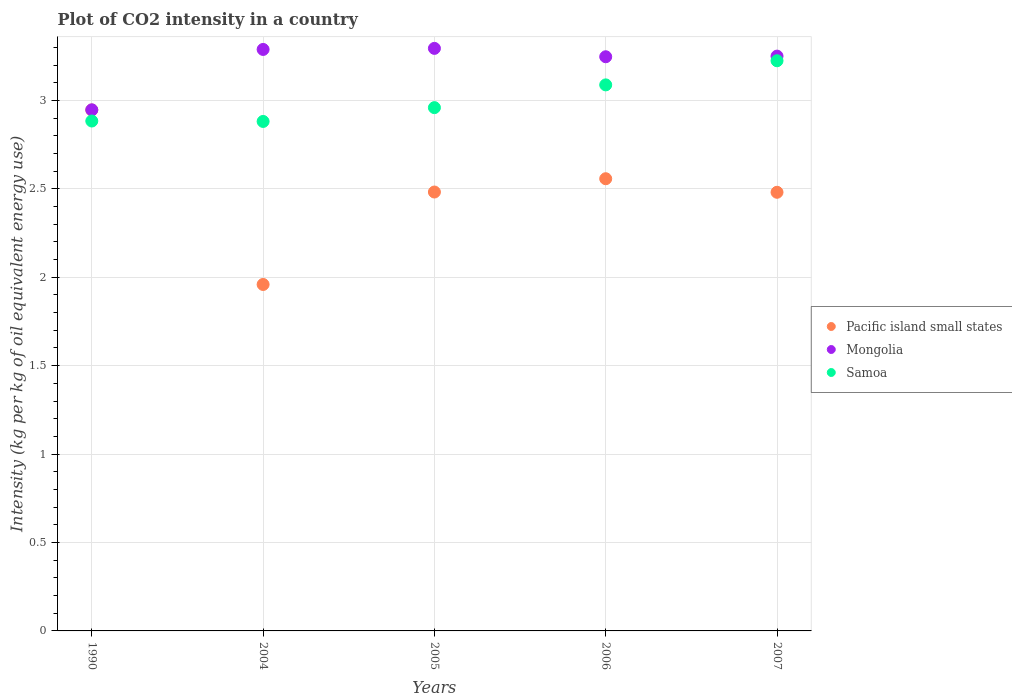How many different coloured dotlines are there?
Your response must be concise. 3. What is the CO2 intensity in in Pacific island small states in 1990?
Your answer should be very brief. 2.95. Across all years, what is the maximum CO2 intensity in in Pacific island small states?
Offer a terse response. 2.95. Across all years, what is the minimum CO2 intensity in in Samoa?
Your answer should be very brief. 2.88. In which year was the CO2 intensity in in Samoa maximum?
Offer a terse response. 2007. What is the total CO2 intensity in in Pacific island small states in the graph?
Give a very brief answer. 12.43. What is the difference between the CO2 intensity in in Mongolia in 2004 and that in 2006?
Your answer should be very brief. 0.04. What is the difference between the CO2 intensity in in Pacific island small states in 1990 and the CO2 intensity in in Mongolia in 2007?
Make the answer very short. -0.3. What is the average CO2 intensity in in Samoa per year?
Offer a terse response. 3.01. In the year 2004, what is the difference between the CO2 intensity in in Mongolia and CO2 intensity in in Pacific island small states?
Provide a succinct answer. 1.33. What is the ratio of the CO2 intensity in in Samoa in 2004 to that in 2007?
Provide a short and direct response. 0.89. What is the difference between the highest and the second highest CO2 intensity in in Mongolia?
Ensure brevity in your answer.  0.01. What is the difference between the highest and the lowest CO2 intensity in in Mongolia?
Give a very brief answer. 0.35. In how many years, is the CO2 intensity in in Pacific island small states greater than the average CO2 intensity in in Pacific island small states taken over all years?
Offer a very short reply. 2. Is the sum of the CO2 intensity in in Pacific island small states in 2004 and 2005 greater than the maximum CO2 intensity in in Mongolia across all years?
Give a very brief answer. Yes. Is it the case that in every year, the sum of the CO2 intensity in in Samoa and CO2 intensity in in Pacific island small states  is greater than the CO2 intensity in in Mongolia?
Provide a succinct answer. Yes. Does the CO2 intensity in in Pacific island small states monotonically increase over the years?
Offer a terse response. No. Is the CO2 intensity in in Mongolia strictly greater than the CO2 intensity in in Pacific island small states over the years?
Your response must be concise. Yes. What is the difference between two consecutive major ticks on the Y-axis?
Offer a terse response. 0.5. Are the values on the major ticks of Y-axis written in scientific E-notation?
Give a very brief answer. No. Does the graph contain any zero values?
Offer a very short reply. No. What is the title of the graph?
Offer a terse response. Plot of CO2 intensity in a country. Does "Japan" appear as one of the legend labels in the graph?
Your answer should be very brief. No. What is the label or title of the X-axis?
Your answer should be very brief. Years. What is the label or title of the Y-axis?
Provide a succinct answer. Intensity (kg per kg of oil equivalent energy use). What is the Intensity (kg per kg of oil equivalent energy use) in Pacific island small states in 1990?
Your answer should be very brief. 2.95. What is the Intensity (kg per kg of oil equivalent energy use) of Mongolia in 1990?
Your response must be concise. 2.95. What is the Intensity (kg per kg of oil equivalent energy use) in Samoa in 1990?
Ensure brevity in your answer.  2.88. What is the Intensity (kg per kg of oil equivalent energy use) of Pacific island small states in 2004?
Offer a terse response. 1.96. What is the Intensity (kg per kg of oil equivalent energy use) in Mongolia in 2004?
Provide a succinct answer. 3.29. What is the Intensity (kg per kg of oil equivalent energy use) in Samoa in 2004?
Make the answer very short. 2.88. What is the Intensity (kg per kg of oil equivalent energy use) in Pacific island small states in 2005?
Provide a short and direct response. 2.48. What is the Intensity (kg per kg of oil equivalent energy use) in Mongolia in 2005?
Your answer should be compact. 3.29. What is the Intensity (kg per kg of oil equivalent energy use) in Samoa in 2005?
Offer a very short reply. 2.96. What is the Intensity (kg per kg of oil equivalent energy use) of Pacific island small states in 2006?
Provide a succinct answer. 2.56. What is the Intensity (kg per kg of oil equivalent energy use) in Mongolia in 2006?
Provide a succinct answer. 3.25. What is the Intensity (kg per kg of oil equivalent energy use) of Samoa in 2006?
Keep it short and to the point. 3.09. What is the Intensity (kg per kg of oil equivalent energy use) in Pacific island small states in 2007?
Offer a terse response. 2.48. What is the Intensity (kg per kg of oil equivalent energy use) in Mongolia in 2007?
Provide a succinct answer. 3.25. What is the Intensity (kg per kg of oil equivalent energy use) in Samoa in 2007?
Offer a very short reply. 3.22. Across all years, what is the maximum Intensity (kg per kg of oil equivalent energy use) of Pacific island small states?
Offer a very short reply. 2.95. Across all years, what is the maximum Intensity (kg per kg of oil equivalent energy use) of Mongolia?
Offer a terse response. 3.29. Across all years, what is the maximum Intensity (kg per kg of oil equivalent energy use) of Samoa?
Make the answer very short. 3.22. Across all years, what is the minimum Intensity (kg per kg of oil equivalent energy use) in Pacific island small states?
Your response must be concise. 1.96. Across all years, what is the minimum Intensity (kg per kg of oil equivalent energy use) of Mongolia?
Offer a very short reply. 2.95. Across all years, what is the minimum Intensity (kg per kg of oil equivalent energy use) of Samoa?
Offer a very short reply. 2.88. What is the total Intensity (kg per kg of oil equivalent energy use) in Pacific island small states in the graph?
Give a very brief answer. 12.43. What is the total Intensity (kg per kg of oil equivalent energy use) in Mongolia in the graph?
Make the answer very short. 16.03. What is the total Intensity (kg per kg of oil equivalent energy use) of Samoa in the graph?
Give a very brief answer. 15.04. What is the difference between the Intensity (kg per kg of oil equivalent energy use) in Pacific island small states in 1990 and that in 2004?
Make the answer very short. 0.99. What is the difference between the Intensity (kg per kg of oil equivalent energy use) of Mongolia in 1990 and that in 2004?
Offer a terse response. -0.34. What is the difference between the Intensity (kg per kg of oil equivalent energy use) in Samoa in 1990 and that in 2004?
Provide a short and direct response. 0. What is the difference between the Intensity (kg per kg of oil equivalent energy use) in Pacific island small states in 1990 and that in 2005?
Offer a very short reply. 0.46. What is the difference between the Intensity (kg per kg of oil equivalent energy use) of Mongolia in 1990 and that in 2005?
Provide a short and direct response. -0.35. What is the difference between the Intensity (kg per kg of oil equivalent energy use) of Samoa in 1990 and that in 2005?
Give a very brief answer. -0.08. What is the difference between the Intensity (kg per kg of oil equivalent energy use) of Pacific island small states in 1990 and that in 2006?
Ensure brevity in your answer.  0.39. What is the difference between the Intensity (kg per kg of oil equivalent energy use) of Mongolia in 1990 and that in 2006?
Keep it short and to the point. -0.3. What is the difference between the Intensity (kg per kg of oil equivalent energy use) of Samoa in 1990 and that in 2006?
Your answer should be compact. -0.2. What is the difference between the Intensity (kg per kg of oil equivalent energy use) of Pacific island small states in 1990 and that in 2007?
Your answer should be very brief. 0.47. What is the difference between the Intensity (kg per kg of oil equivalent energy use) of Mongolia in 1990 and that in 2007?
Keep it short and to the point. -0.3. What is the difference between the Intensity (kg per kg of oil equivalent energy use) in Samoa in 1990 and that in 2007?
Ensure brevity in your answer.  -0.34. What is the difference between the Intensity (kg per kg of oil equivalent energy use) in Pacific island small states in 2004 and that in 2005?
Keep it short and to the point. -0.52. What is the difference between the Intensity (kg per kg of oil equivalent energy use) in Mongolia in 2004 and that in 2005?
Ensure brevity in your answer.  -0.01. What is the difference between the Intensity (kg per kg of oil equivalent energy use) of Samoa in 2004 and that in 2005?
Offer a very short reply. -0.08. What is the difference between the Intensity (kg per kg of oil equivalent energy use) of Pacific island small states in 2004 and that in 2006?
Provide a short and direct response. -0.6. What is the difference between the Intensity (kg per kg of oil equivalent energy use) in Mongolia in 2004 and that in 2006?
Ensure brevity in your answer.  0.04. What is the difference between the Intensity (kg per kg of oil equivalent energy use) in Samoa in 2004 and that in 2006?
Provide a succinct answer. -0.21. What is the difference between the Intensity (kg per kg of oil equivalent energy use) in Pacific island small states in 2004 and that in 2007?
Your answer should be very brief. -0.52. What is the difference between the Intensity (kg per kg of oil equivalent energy use) of Mongolia in 2004 and that in 2007?
Your answer should be very brief. 0.04. What is the difference between the Intensity (kg per kg of oil equivalent energy use) of Samoa in 2004 and that in 2007?
Your answer should be very brief. -0.34. What is the difference between the Intensity (kg per kg of oil equivalent energy use) in Pacific island small states in 2005 and that in 2006?
Offer a very short reply. -0.08. What is the difference between the Intensity (kg per kg of oil equivalent energy use) in Mongolia in 2005 and that in 2006?
Provide a succinct answer. 0.05. What is the difference between the Intensity (kg per kg of oil equivalent energy use) in Samoa in 2005 and that in 2006?
Provide a short and direct response. -0.13. What is the difference between the Intensity (kg per kg of oil equivalent energy use) in Pacific island small states in 2005 and that in 2007?
Offer a very short reply. 0. What is the difference between the Intensity (kg per kg of oil equivalent energy use) in Mongolia in 2005 and that in 2007?
Give a very brief answer. 0.04. What is the difference between the Intensity (kg per kg of oil equivalent energy use) of Samoa in 2005 and that in 2007?
Your answer should be compact. -0.27. What is the difference between the Intensity (kg per kg of oil equivalent energy use) in Pacific island small states in 2006 and that in 2007?
Offer a terse response. 0.08. What is the difference between the Intensity (kg per kg of oil equivalent energy use) of Mongolia in 2006 and that in 2007?
Provide a short and direct response. -0. What is the difference between the Intensity (kg per kg of oil equivalent energy use) in Samoa in 2006 and that in 2007?
Make the answer very short. -0.14. What is the difference between the Intensity (kg per kg of oil equivalent energy use) in Pacific island small states in 1990 and the Intensity (kg per kg of oil equivalent energy use) in Mongolia in 2004?
Keep it short and to the point. -0.34. What is the difference between the Intensity (kg per kg of oil equivalent energy use) in Pacific island small states in 1990 and the Intensity (kg per kg of oil equivalent energy use) in Samoa in 2004?
Your answer should be compact. 0.06. What is the difference between the Intensity (kg per kg of oil equivalent energy use) of Mongolia in 1990 and the Intensity (kg per kg of oil equivalent energy use) of Samoa in 2004?
Your answer should be very brief. 0.07. What is the difference between the Intensity (kg per kg of oil equivalent energy use) of Pacific island small states in 1990 and the Intensity (kg per kg of oil equivalent energy use) of Mongolia in 2005?
Give a very brief answer. -0.35. What is the difference between the Intensity (kg per kg of oil equivalent energy use) in Pacific island small states in 1990 and the Intensity (kg per kg of oil equivalent energy use) in Samoa in 2005?
Offer a very short reply. -0.01. What is the difference between the Intensity (kg per kg of oil equivalent energy use) of Mongolia in 1990 and the Intensity (kg per kg of oil equivalent energy use) of Samoa in 2005?
Your answer should be compact. -0.01. What is the difference between the Intensity (kg per kg of oil equivalent energy use) of Pacific island small states in 1990 and the Intensity (kg per kg of oil equivalent energy use) of Mongolia in 2006?
Provide a short and direct response. -0.3. What is the difference between the Intensity (kg per kg of oil equivalent energy use) of Pacific island small states in 1990 and the Intensity (kg per kg of oil equivalent energy use) of Samoa in 2006?
Keep it short and to the point. -0.14. What is the difference between the Intensity (kg per kg of oil equivalent energy use) of Mongolia in 1990 and the Intensity (kg per kg of oil equivalent energy use) of Samoa in 2006?
Provide a short and direct response. -0.14. What is the difference between the Intensity (kg per kg of oil equivalent energy use) of Pacific island small states in 1990 and the Intensity (kg per kg of oil equivalent energy use) of Mongolia in 2007?
Your answer should be compact. -0.3. What is the difference between the Intensity (kg per kg of oil equivalent energy use) in Pacific island small states in 1990 and the Intensity (kg per kg of oil equivalent energy use) in Samoa in 2007?
Your answer should be very brief. -0.28. What is the difference between the Intensity (kg per kg of oil equivalent energy use) in Mongolia in 1990 and the Intensity (kg per kg of oil equivalent energy use) in Samoa in 2007?
Your response must be concise. -0.28. What is the difference between the Intensity (kg per kg of oil equivalent energy use) of Pacific island small states in 2004 and the Intensity (kg per kg of oil equivalent energy use) of Mongolia in 2005?
Keep it short and to the point. -1.34. What is the difference between the Intensity (kg per kg of oil equivalent energy use) in Pacific island small states in 2004 and the Intensity (kg per kg of oil equivalent energy use) in Samoa in 2005?
Give a very brief answer. -1. What is the difference between the Intensity (kg per kg of oil equivalent energy use) of Mongolia in 2004 and the Intensity (kg per kg of oil equivalent energy use) of Samoa in 2005?
Your response must be concise. 0.33. What is the difference between the Intensity (kg per kg of oil equivalent energy use) in Pacific island small states in 2004 and the Intensity (kg per kg of oil equivalent energy use) in Mongolia in 2006?
Make the answer very short. -1.29. What is the difference between the Intensity (kg per kg of oil equivalent energy use) of Pacific island small states in 2004 and the Intensity (kg per kg of oil equivalent energy use) of Samoa in 2006?
Provide a succinct answer. -1.13. What is the difference between the Intensity (kg per kg of oil equivalent energy use) of Mongolia in 2004 and the Intensity (kg per kg of oil equivalent energy use) of Samoa in 2006?
Your answer should be compact. 0.2. What is the difference between the Intensity (kg per kg of oil equivalent energy use) in Pacific island small states in 2004 and the Intensity (kg per kg of oil equivalent energy use) in Mongolia in 2007?
Your answer should be very brief. -1.29. What is the difference between the Intensity (kg per kg of oil equivalent energy use) of Pacific island small states in 2004 and the Intensity (kg per kg of oil equivalent energy use) of Samoa in 2007?
Provide a succinct answer. -1.27. What is the difference between the Intensity (kg per kg of oil equivalent energy use) in Mongolia in 2004 and the Intensity (kg per kg of oil equivalent energy use) in Samoa in 2007?
Offer a very short reply. 0.06. What is the difference between the Intensity (kg per kg of oil equivalent energy use) in Pacific island small states in 2005 and the Intensity (kg per kg of oil equivalent energy use) in Mongolia in 2006?
Offer a terse response. -0.77. What is the difference between the Intensity (kg per kg of oil equivalent energy use) in Pacific island small states in 2005 and the Intensity (kg per kg of oil equivalent energy use) in Samoa in 2006?
Ensure brevity in your answer.  -0.61. What is the difference between the Intensity (kg per kg of oil equivalent energy use) of Mongolia in 2005 and the Intensity (kg per kg of oil equivalent energy use) of Samoa in 2006?
Give a very brief answer. 0.21. What is the difference between the Intensity (kg per kg of oil equivalent energy use) of Pacific island small states in 2005 and the Intensity (kg per kg of oil equivalent energy use) of Mongolia in 2007?
Your answer should be compact. -0.77. What is the difference between the Intensity (kg per kg of oil equivalent energy use) of Pacific island small states in 2005 and the Intensity (kg per kg of oil equivalent energy use) of Samoa in 2007?
Provide a succinct answer. -0.74. What is the difference between the Intensity (kg per kg of oil equivalent energy use) of Mongolia in 2005 and the Intensity (kg per kg of oil equivalent energy use) of Samoa in 2007?
Provide a succinct answer. 0.07. What is the difference between the Intensity (kg per kg of oil equivalent energy use) of Pacific island small states in 2006 and the Intensity (kg per kg of oil equivalent energy use) of Mongolia in 2007?
Ensure brevity in your answer.  -0.69. What is the difference between the Intensity (kg per kg of oil equivalent energy use) of Pacific island small states in 2006 and the Intensity (kg per kg of oil equivalent energy use) of Samoa in 2007?
Provide a succinct answer. -0.67. What is the difference between the Intensity (kg per kg of oil equivalent energy use) of Mongolia in 2006 and the Intensity (kg per kg of oil equivalent energy use) of Samoa in 2007?
Offer a very short reply. 0.02. What is the average Intensity (kg per kg of oil equivalent energy use) in Pacific island small states per year?
Give a very brief answer. 2.48. What is the average Intensity (kg per kg of oil equivalent energy use) in Mongolia per year?
Keep it short and to the point. 3.21. What is the average Intensity (kg per kg of oil equivalent energy use) in Samoa per year?
Provide a short and direct response. 3.01. In the year 1990, what is the difference between the Intensity (kg per kg of oil equivalent energy use) of Pacific island small states and Intensity (kg per kg of oil equivalent energy use) of Mongolia?
Your answer should be compact. -0. In the year 1990, what is the difference between the Intensity (kg per kg of oil equivalent energy use) of Pacific island small states and Intensity (kg per kg of oil equivalent energy use) of Samoa?
Ensure brevity in your answer.  0.06. In the year 1990, what is the difference between the Intensity (kg per kg of oil equivalent energy use) of Mongolia and Intensity (kg per kg of oil equivalent energy use) of Samoa?
Your answer should be very brief. 0.06. In the year 2004, what is the difference between the Intensity (kg per kg of oil equivalent energy use) in Pacific island small states and Intensity (kg per kg of oil equivalent energy use) in Mongolia?
Ensure brevity in your answer.  -1.33. In the year 2004, what is the difference between the Intensity (kg per kg of oil equivalent energy use) in Pacific island small states and Intensity (kg per kg of oil equivalent energy use) in Samoa?
Your answer should be very brief. -0.92. In the year 2004, what is the difference between the Intensity (kg per kg of oil equivalent energy use) of Mongolia and Intensity (kg per kg of oil equivalent energy use) of Samoa?
Your response must be concise. 0.41. In the year 2005, what is the difference between the Intensity (kg per kg of oil equivalent energy use) of Pacific island small states and Intensity (kg per kg of oil equivalent energy use) of Mongolia?
Offer a very short reply. -0.81. In the year 2005, what is the difference between the Intensity (kg per kg of oil equivalent energy use) in Pacific island small states and Intensity (kg per kg of oil equivalent energy use) in Samoa?
Offer a very short reply. -0.48. In the year 2005, what is the difference between the Intensity (kg per kg of oil equivalent energy use) of Mongolia and Intensity (kg per kg of oil equivalent energy use) of Samoa?
Your answer should be very brief. 0.34. In the year 2006, what is the difference between the Intensity (kg per kg of oil equivalent energy use) of Pacific island small states and Intensity (kg per kg of oil equivalent energy use) of Mongolia?
Give a very brief answer. -0.69. In the year 2006, what is the difference between the Intensity (kg per kg of oil equivalent energy use) in Pacific island small states and Intensity (kg per kg of oil equivalent energy use) in Samoa?
Provide a succinct answer. -0.53. In the year 2006, what is the difference between the Intensity (kg per kg of oil equivalent energy use) in Mongolia and Intensity (kg per kg of oil equivalent energy use) in Samoa?
Offer a terse response. 0.16. In the year 2007, what is the difference between the Intensity (kg per kg of oil equivalent energy use) in Pacific island small states and Intensity (kg per kg of oil equivalent energy use) in Mongolia?
Offer a terse response. -0.77. In the year 2007, what is the difference between the Intensity (kg per kg of oil equivalent energy use) of Pacific island small states and Intensity (kg per kg of oil equivalent energy use) of Samoa?
Make the answer very short. -0.74. In the year 2007, what is the difference between the Intensity (kg per kg of oil equivalent energy use) in Mongolia and Intensity (kg per kg of oil equivalent energy use) in Samoa?
Offer a very short reply. 0.03. What is the ratio of the Intensity (kg per kg of oil equivalent energy use) in Pacific island small states in 1990 to that in 2004?
Keep it short and to the point. 1.5. What is the ratio of the Intensity (kg per kg of oil equivalent energy use) of Mongolia in 1990 to that in 2004?
Your response must be concise. 0.9. What is the ratio of the Intensity (kg per kg of oil equivalent energy use) in Pacific island small states in 1990 to that in 2005?
Give a very brief answer. 1.19. What is the ratio of the Intensity (kg per kg of oil equivalent energy use) in Mongolia in 1990 to that in 2005?
Make the answer very short. 0.89. What is the ratio of the Intensity (kg per kg of oil equivalent energy use) of Samoa in 1990 to that in 2005?
Your answer should be very brief. 0.97. What is the ratio of the Intensity (kg per kg of oil equivalent energy use) of Pacific island small states in 1990 to that in 2006?
Keep it short and to the point. 1.15. What is the ratio of the Intensity (kg per kg of oil equivalent energy use) in Mongolia in 1990 to that in 2006?
Keep it short and to the point. 0.91. What is the ratio of the Intensity (kg per kg of oil equivalent energy use) of Samoa in 1990 to that in 2006?
Give a very brief answer. 0.93. What is the ratio of the Intensity (kg per kg of oil equivalent energy use) in Pacific island small states in 1990 to that in 2007?
Offer a terse response. 1.19. What is the ratio of the Intensity (kg per kg of oil equivalent energy use) of Mongolia in 1990 to that in 2007?
Your answer should be very brief. 0.91. What is the ratio of the Intensity (kg per kg of oil equivalent energy use) in Samoa in 1990 to that in 2007?
Your response must be concise. 0.89. What is the ratio of the Intensity (kg per kg of oil equivalent energy use) in Pacific island small states in 2004 to that in 2005?
Your response must be concise. 0.79. What is the ratio of the Intensity (kg per kg of oil equivalent energy use) of Mongolia in 2004 to that in 2005?
Ensure brevity in your answer.  1. What is the ratio of the Intensity (kg per kg of oil equivalent energy use) of Samoa in 2004 to that in 2005?
Provide a succinct answer. 0.97. What is the ratio of the Intensity (kg per kg of oil equivalent energy use) of Pacific island small states in 2004 to that in 2006?
Your answer should be compact. 0.77. What is the ratio of the Intensity (kg per kg of oil equivalent energy use) in Mongolia in 2004 to that in 2006?
Your answer should be compact. 1.01. What is the ratio of the Intensity (kg per kg of oil equivalent energy use) in Samoa in 2004 to that in 2006?
Keep it short and to the point. 0.93. What is the ratio of the Intensity (kg per kg of oil equivalent energy use) in Pacific island small states in 2004 to that in 2007?
Your answer should be compact. 0.79. What is the ratio of the Intensity (kg per kg of oil equivalent energy use) in Mongolia in 2004 to that in 2007?
Offer a terse response. 1.01. What is the ratio of the Intensity (kg per kg of oil equivalent energy use) in Samoa in 2004 to that in 2007?
Make the answer very short. 0.89. What is the ratio of the Intensity (kg per kg of oil equivalent energy use) in Pacific island small states in 2005 to that in 2006?
Offer a terse response. 0.97. What is the ratio of the Intensity (kg per kg of oil equivalent energy use) in Mongolia in 2005 to that in 2006?
Your answer should be compact. 1.01. What is the ratio of the Intensity (kg per kg of oil equivalent energy use) of Mongolia in 2005 to that in 2007?
Keep it short and to the point. 1.01. What is the ratio of the Intensity (kg per kg of oil equivalent energy use) in Samoa in 2005 to that in 2007?
Provide a short and direct response. 0.92. What is the ratio of the Intensity (kg per kg of oil equivalent energy use) of Pacific island small states in 2006 to that in 2007?
Give a very brief answer. 1.03. What is the ratio of the Intensity (kg per kg of oil equivalent energy use) of Samoa in 2006 to that in 2007?
Your response must be concise. 0.96. What is the difference between the highest and the second highest Intensity (kg per kg of oil equivalent energy use) in Pacific island small states?
Offer a terse response. 0.39. What is the difference between the highest and the second highest Intensity (kg per kg of oil equivalent energy use) of Mongolia?
Offer a very short reply. 0.01. What is the difference between the highest and the second highest Intensity (kg per kg of oil equivalent energy use) of Samoa?
Offer a terse response. 0.14. What is the difference between the highest and the lowest Intensity (kg per kg of oil equivalent energy use) in Pacific island small states?
Give a very brief answer. 0.99. What is the difference between the highest and the lowest Intensity (kg per kg of oil equivalent energy use) of Mongolia?
Your response must be concise. 0.35. What is the difference between the highest and the lowest Intensity (kg per kg of oil equivalent energy use) in Samoa?
Your answer should be compact. 0.34. 